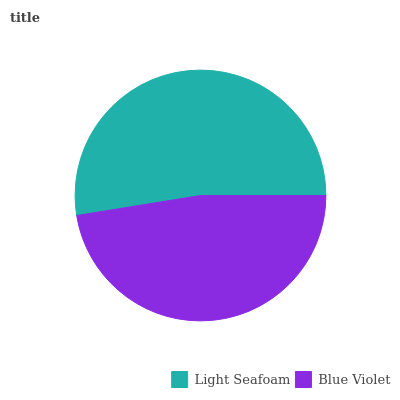Is Blue Violet the minimum?
Answer yes or no. Yes. Is Light Seafoam the maximum?
Answer yes or no. Yes. Is Blue Violet the maximum?
Answer yes or no. No. Is Light Seafoam greater than Blue Violet?
Answer yes or no. Yes. Is Blue Violet less than Light Seafoam?
Answer yes or no. Yes. Is Blue Violet greater than Light Seafoam?
Answer yes or no. No. Is Light Seafoam less than Blue Violet?
Answer yes or no. No. Is Light Seafoam the high median?
Answer yes or no. Yes. Is Blue Violet the low median?
Answer yes or no. Yes. Is Blue Violet the high median?
Answer yes or no. No. Is Light Seafoam the low median?
Answer yes or no. No. 